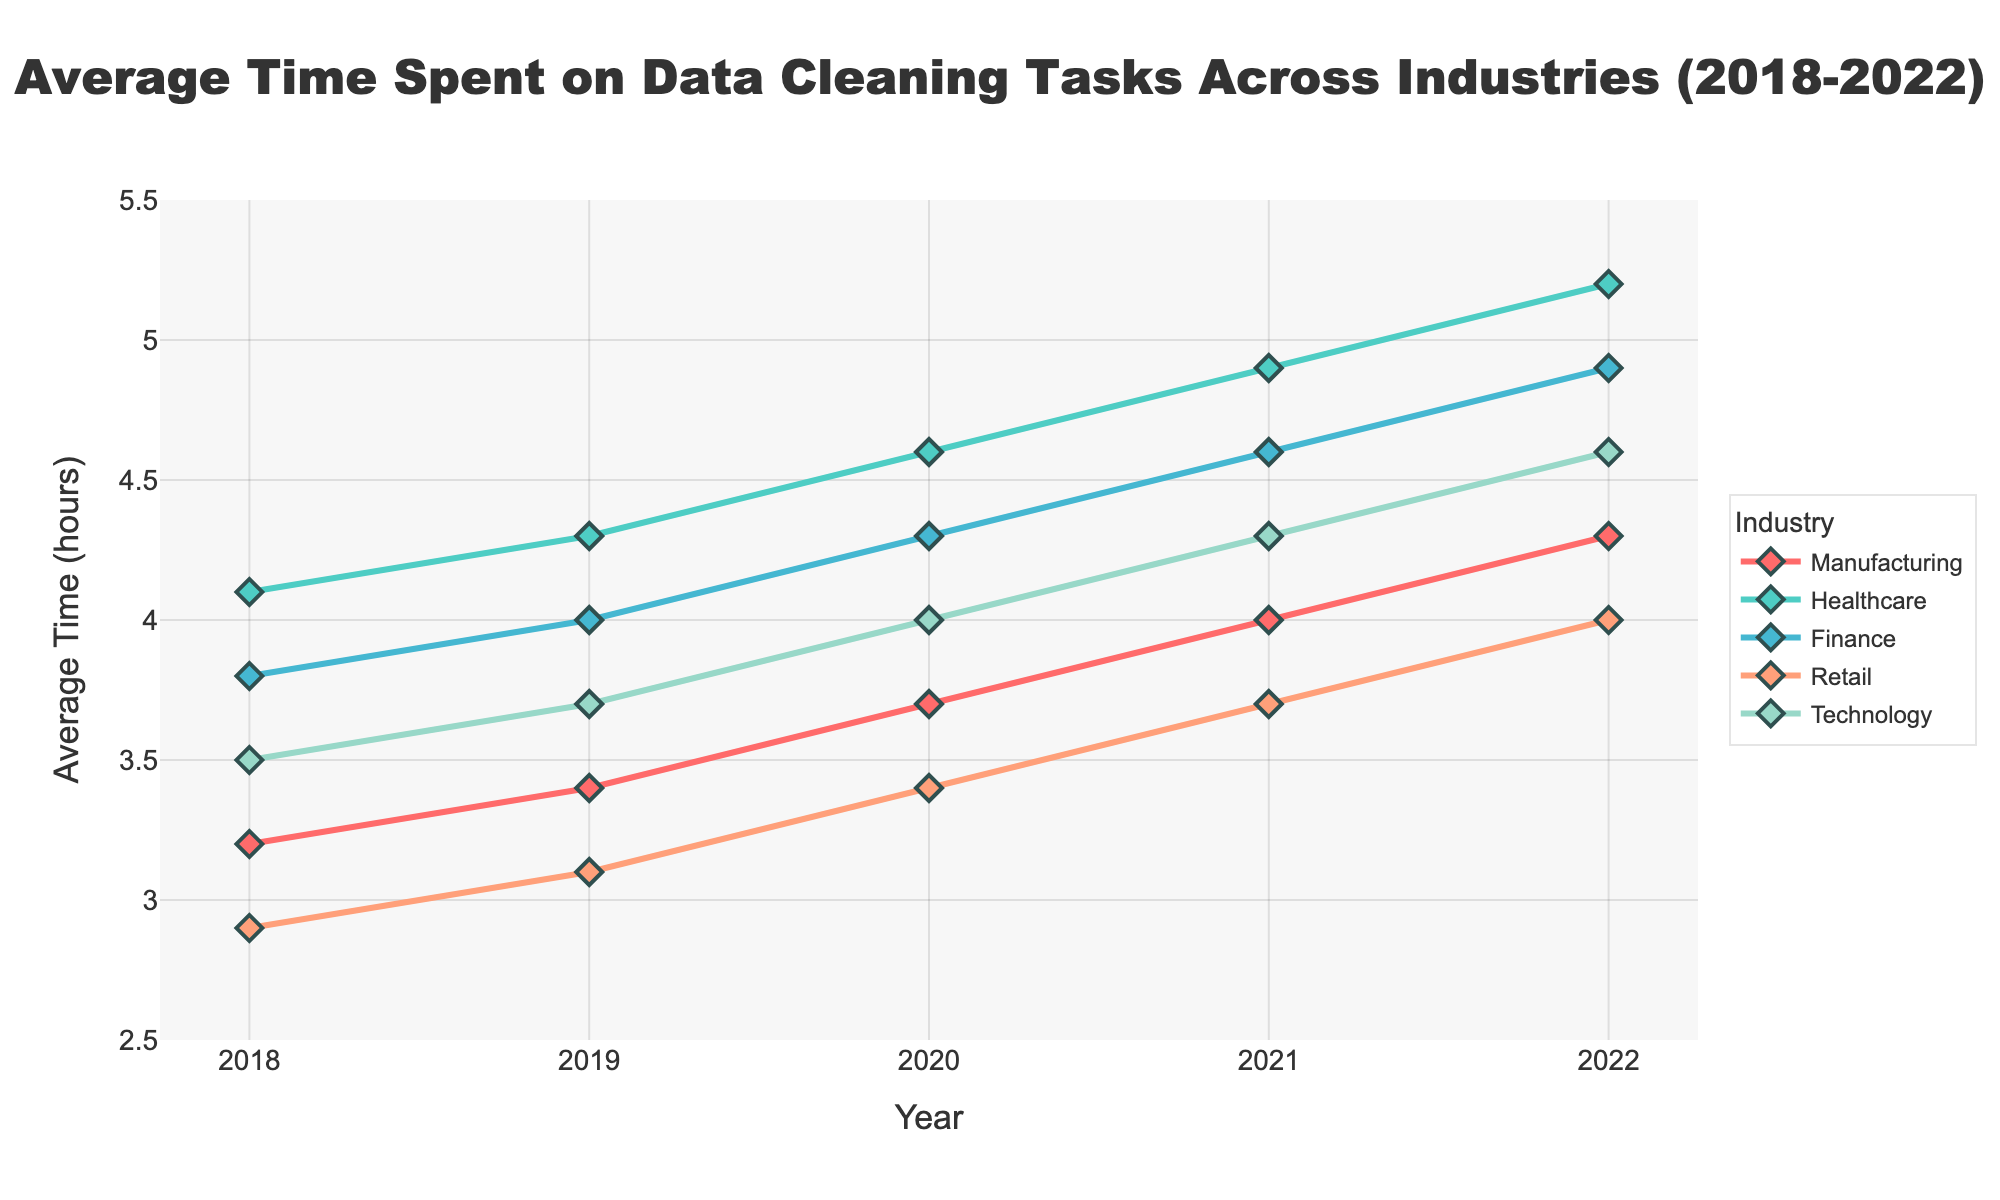Which industry has the highest average time spent on data cleaning tasks in 2018? Look at the values for 2018 for each industry in the line chart. The highest value is for Healthcare.
Answer: Healthcare How much did the average time spent on data cleaning tasks in Manufacturing increase from 2018 to 2022? Subtract the 2018 value from the 2022 value for Manufacturing: 4.3 - 3.2 = 1.1 hours.
Answer: 1.1 hours Which industry showed the least increase in average time spent on data cleaning tasks from 2018 to 2022? Calculate the increase for each industry from 2018 to 2022; the industry with the smallest change is Retail: 4.0 - 2.9 = 1.1.
Answer: Retail In which year did Finance and Technology have the same average time spent on data cleaning tasks? Look for the year where the values for Finance and Technology intersect on the graph. In 2018, both industries had the same value of 3.5.
Answer: 2018 What is the overall trend for Healthcare from 2018 to 2022? Observe the direction of the line for Healthcare from 2018 to 2022. The trend is an increasing one.
Answer: Increasing Between Finance and Manufacturing, which industry had a larger absolute increase in average time spent on data cleaning tasks from 2018 to 2022? Calculate the absolute increase for both industries: Finance (4.9 - 3.8 = 1.1) and Manufacturing (4.3 - 3.2 = 1.1). Both industries have the same increase.
Answer: Both are equal By how much did the average time spent on data cleaning tasks in Retail differ from Technology in 2020? Subtract the 2020 value of Retail from Technology: 4.0 - 3.4 = 0.6 hours.
Answer: 0.6 hours What is the average time spent on data cleaning tasks for all industries combined in 2021? Add the 2021 values for all industries and then divide by the number of industries: (4.0 + 4.9 + 4.6 + 3.7 + 4.3) / 5 = 4.3 hours.
Answer: 4.3 hours In which year did Manufacturing see the highest average time spent on data cleaning tasks? Identify the peak value for Manufacturing by checking each year. The highest value is in 2022.
Answer: 2022 Which industry showed the most significant increase in average time spent on data cleaning tasks between any two consecutive years? Calculate year-over-year increases for each industry and find the maximum: Healthcare displayed the highest increase from 2021 to 2022 (5.2 - 4.9 = 0.3).
Answer: Healthcare 